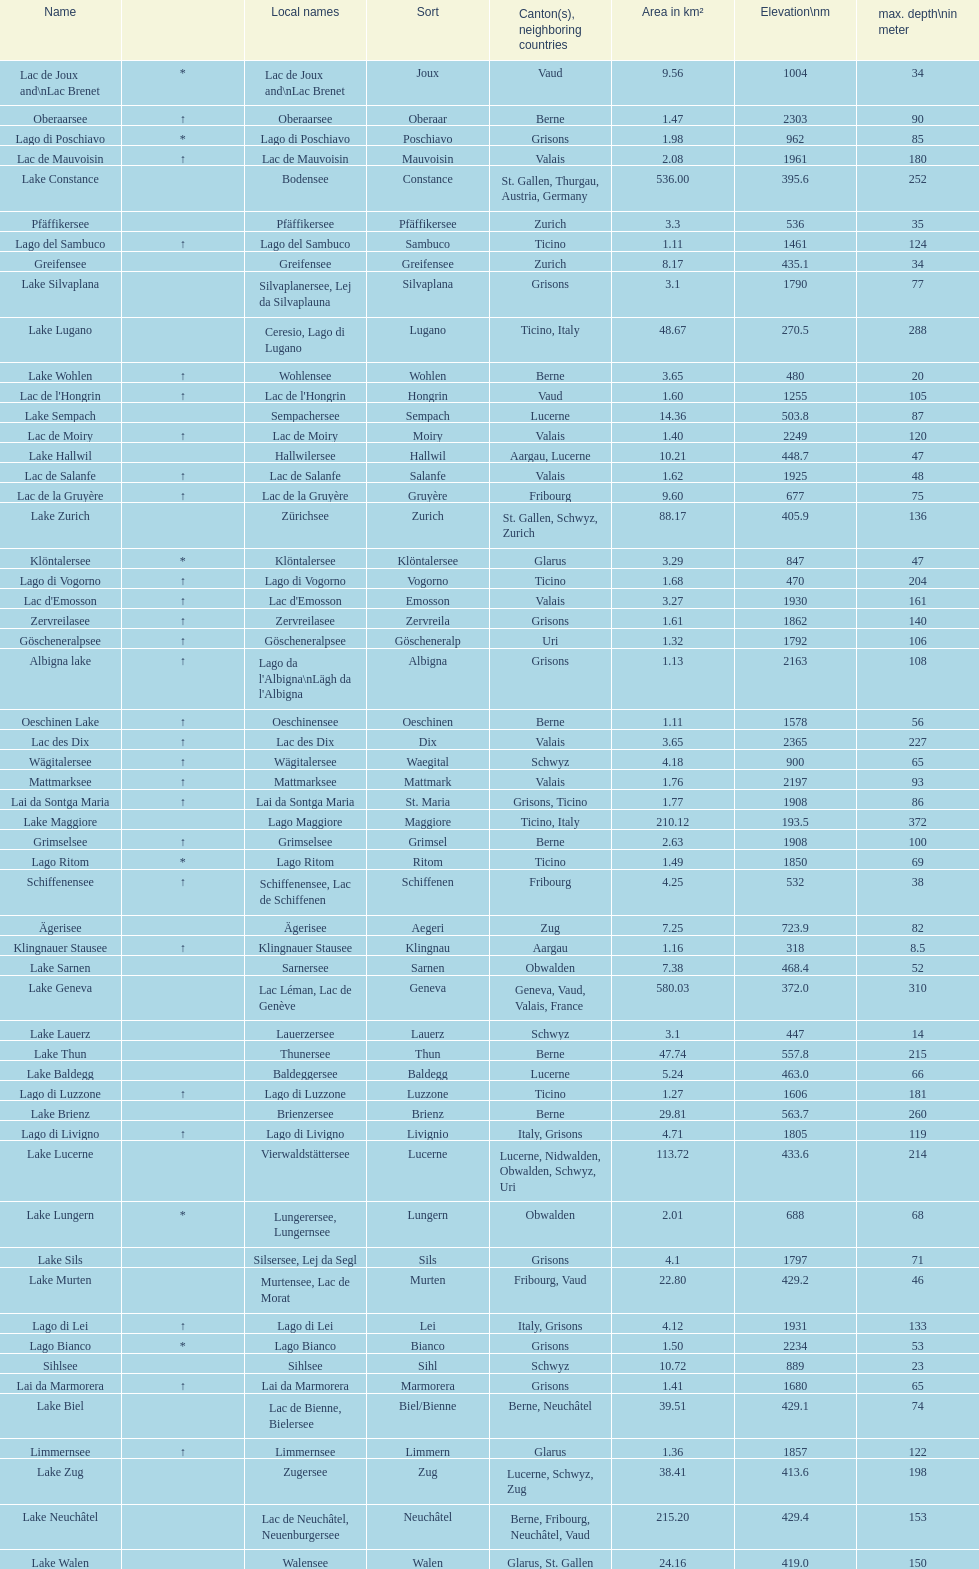What lake has the next highest elevation after lac des dix? Oberaarsee. 